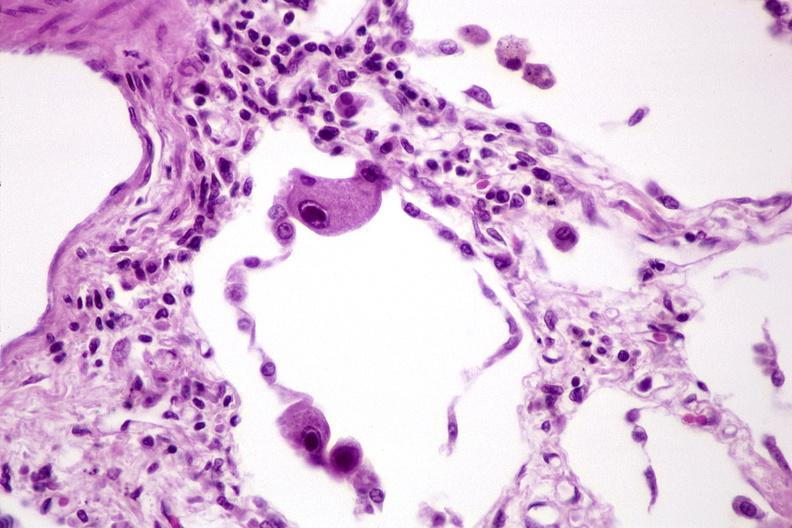what does this image show?
Answer the question using a single word or phrase. Lung 